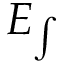Convert formula to latex. <formula><loc_0><loc_0><loc_500><loc_500>E _ { \int }</formula> 